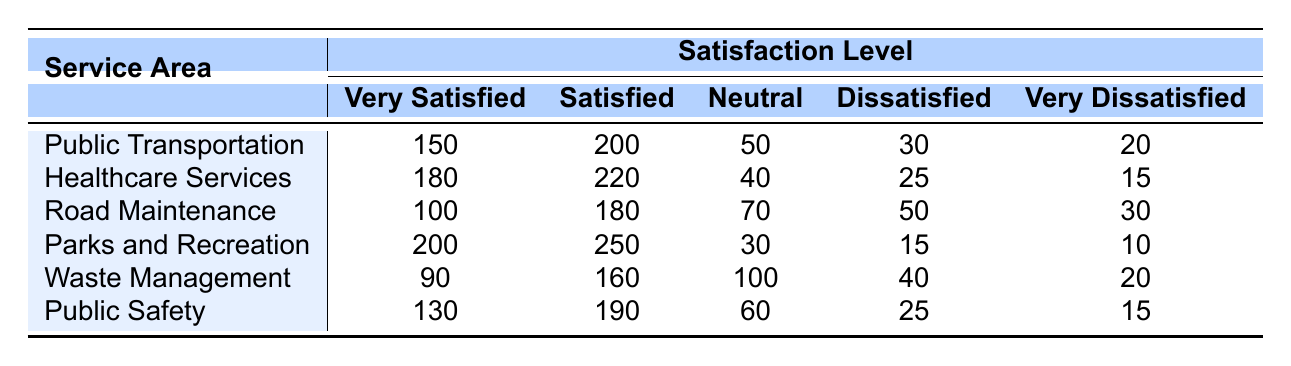What is the total number of respondents for Healthcare Services? Adding all satisfaction levels for Healthcare Services gives us 180 + 220 + 40 + 25 + 15 = 480 respondents.
Answer: 480 Which service area has the highest number of Very Satisfied ratings? Looking at the column for Very Satisfied ratings, Parks and Recreation has 200, which is higher than any other service area listed.
Answer: Parks and Recreation How many more Satisfied ratings are there for Public Transportation compared to Waste Management? The Satisfied ratings are 200 for Public Transportation and 160 for Waste Management. To find the difference, we calculate 200 - 160 = 40.
Answer: 40 Is the number of Very Dissatisfied respondents in Public Safety greater than or equal to those in Waste Management? Public Safety has 15 Very Dissatisfied responses, while Waste Management has 20. Since 15 is less than 20, the statement is false.
Answer: No What is the average number of Neutral ratings across all service areas? Summing Neutral ratings gives us 50 + 40 + 70 + 30 + 100 + 60 = 350. There are 6 service areas, so the average is 350 / 6 ≈ 58.33.
Answer: Approximately 58.33 